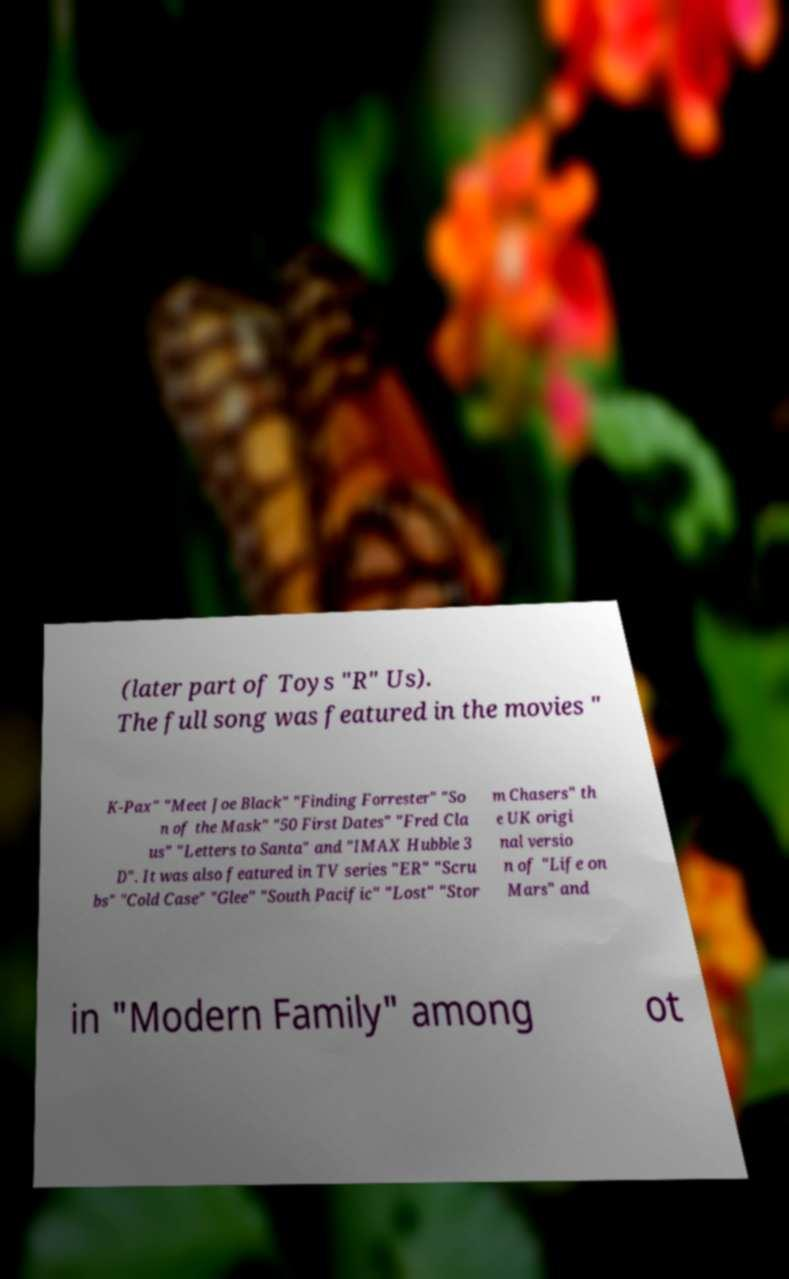Can you read and provide the text displayed in the image?This photo seems to have some interesting text. Can you extract and type it out for me? (later part of Toys "R" Us). The full song was featured in the movies " K-Pax" "Meet Joe Black" "Finding Forrester" "So n of the Mask" "50 First Dates" "Fred Cla us" "Letters to Santa" and "IMAX Hubble 3 D". It was also featured in TV series "ER" "Scru bs" "Cold Case" "Glee" "South Pacific" "Lost" "Stor m Chasers" th e UK origi nal versio n of "Life on Mars" and in "Modern Family" among ot 